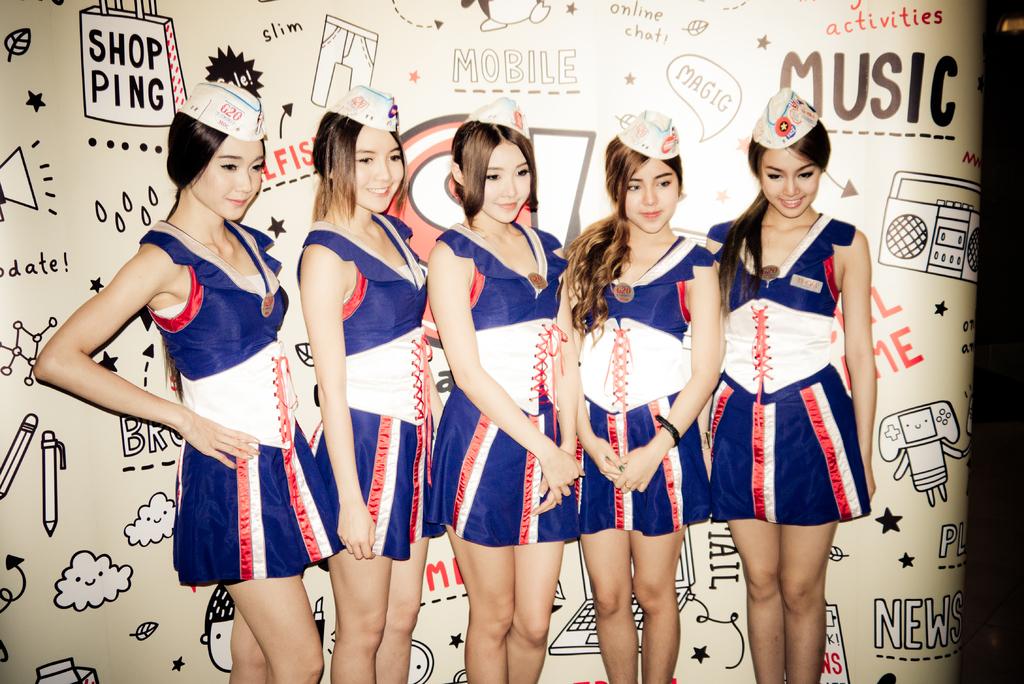What is the word above "music" on the top right corner?
Give a very brief answer. Activities. 